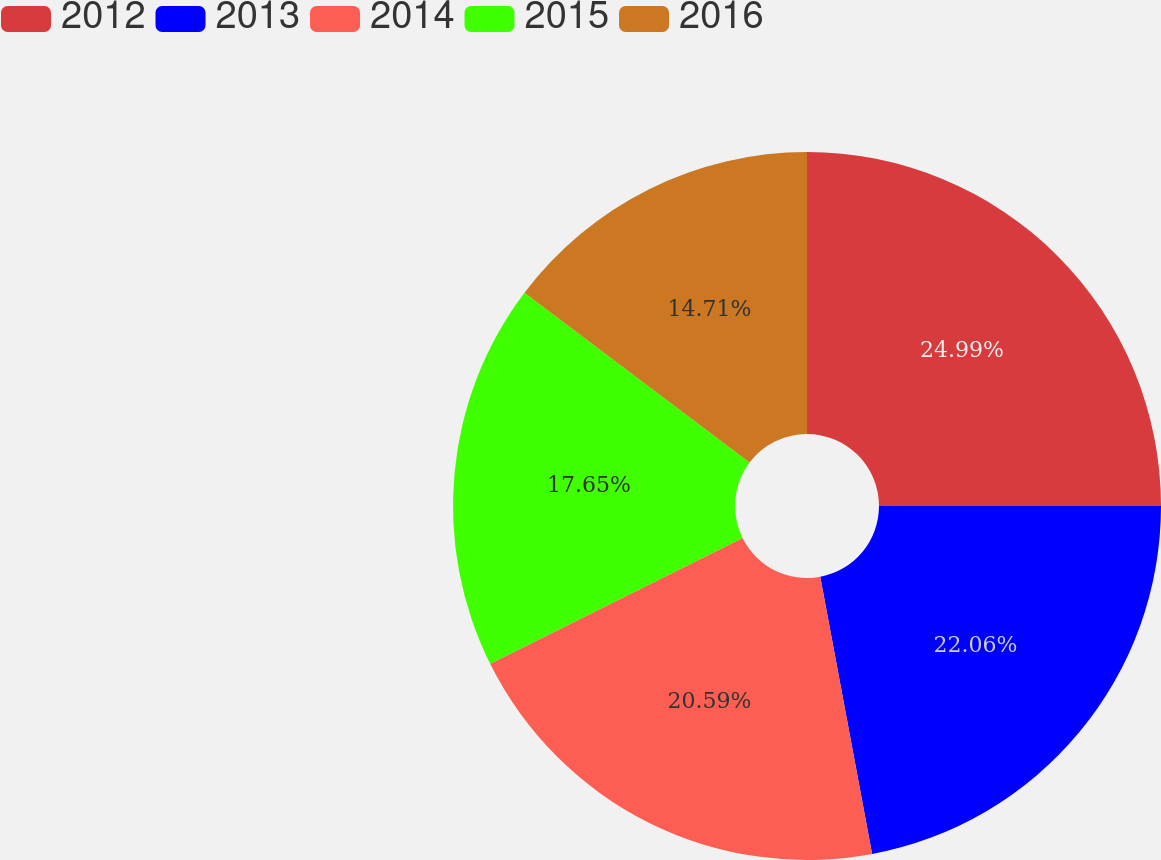Convert chart to OTSL. <chart><loc_0><loc_0><loc_500><loc_500><pie_chart><fcel>2012<fcel>2013<fcel>2014<fcel>2015<fcel>2016<nl><fcel>25.0%<fcel>22.06%<fcel>20.59%<fcel>17.65%<fcel>14.71%<nl></chart> 